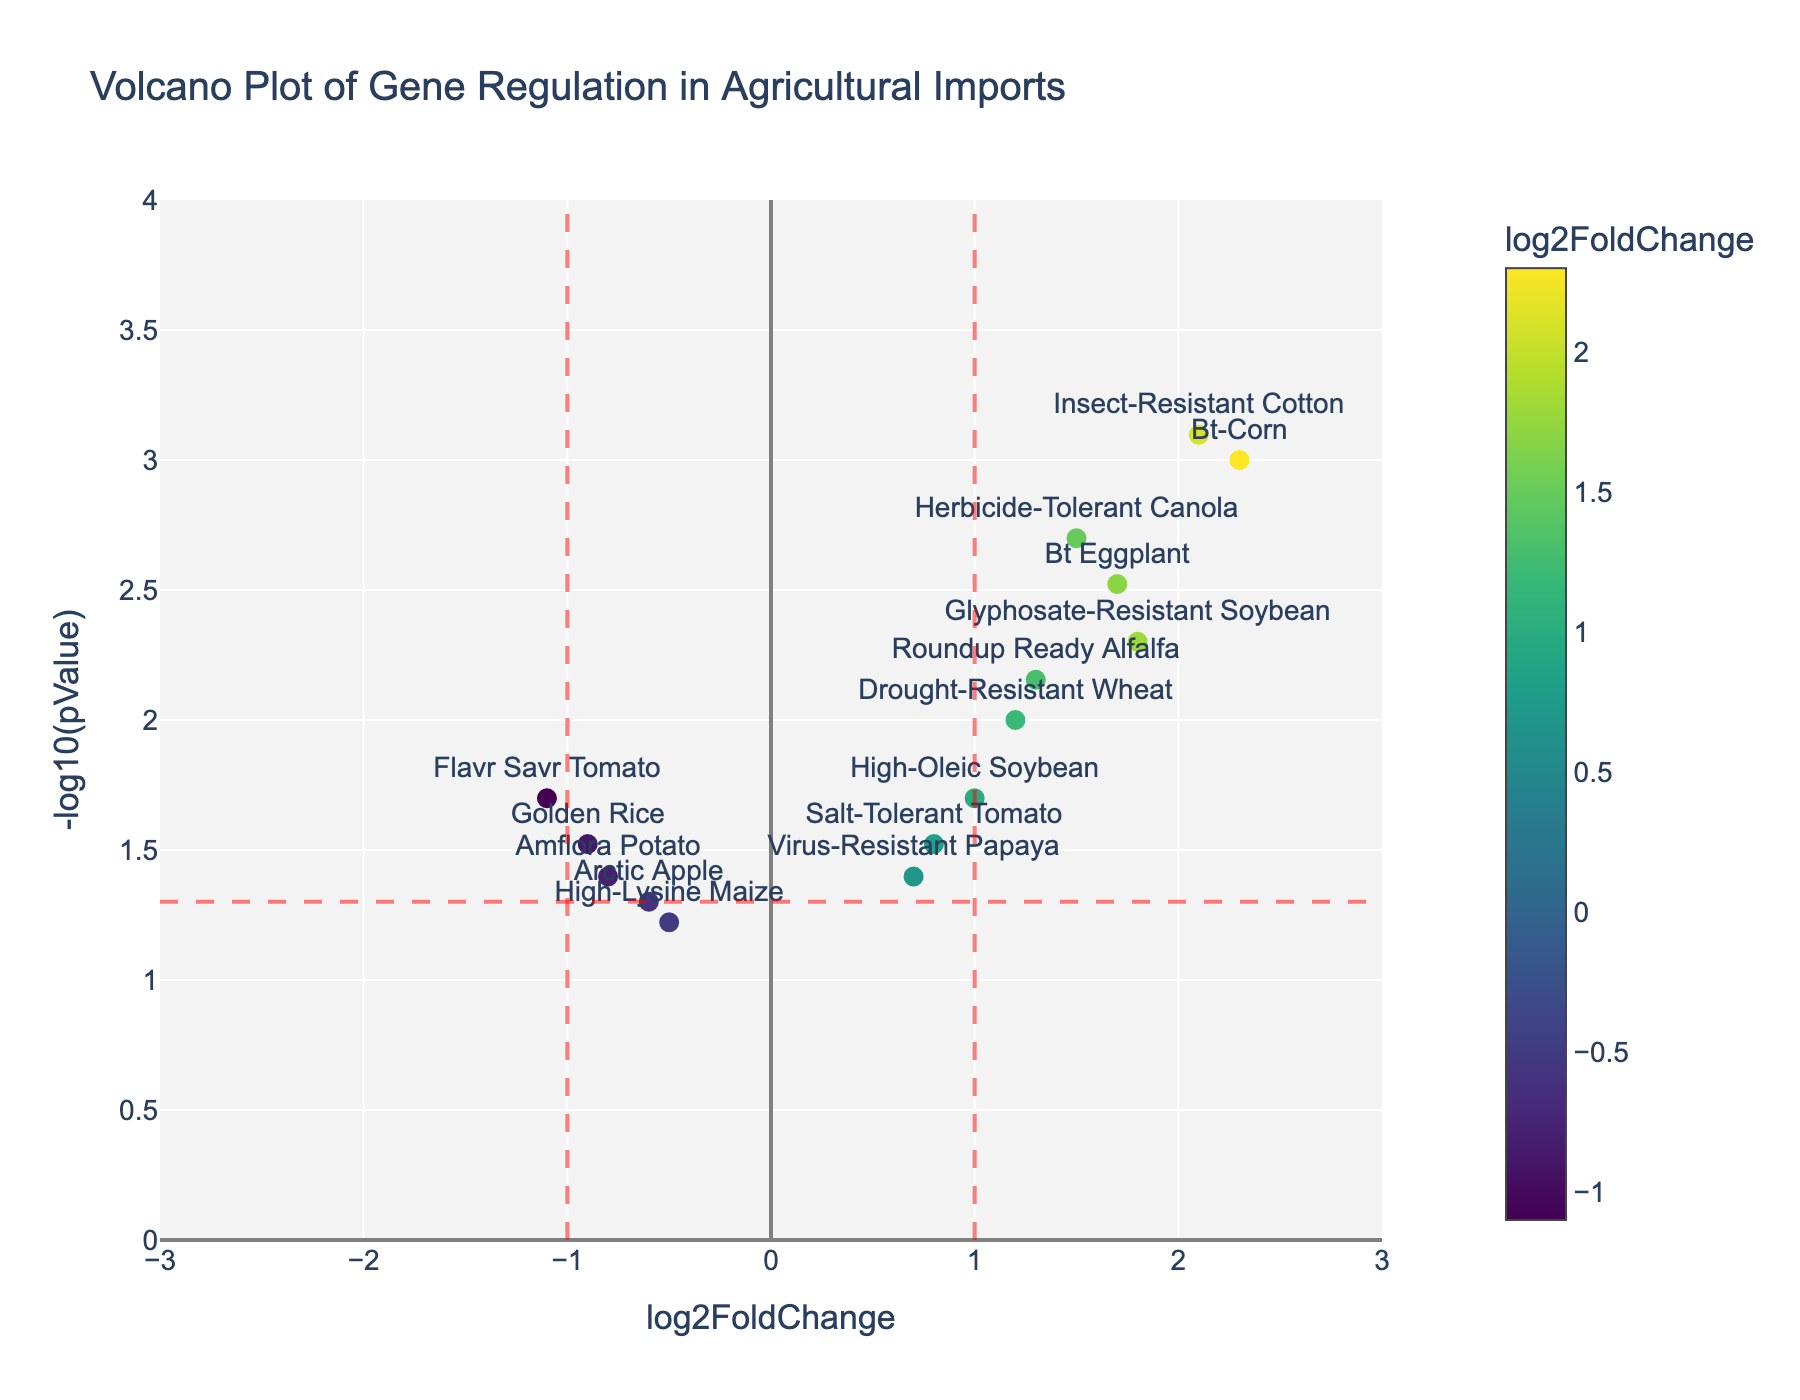How many genes show a significant log2FoldChange greater than 1? We consider a log2FoldChange significant if the value is greater than 1 and the p-value is less than 0.05. By looking at the plot, we find that Bt-Corn, Glyphosate-Resistant Soybean, Herbicide-Tolerant Canola, Insect-Resistant Cotton, Roundup Ready Alfalfa, and Bt Eggplant satisfy these conditions.
Answer: 6 Which gene has the highest -log10(pValue)? The -log10(pValue) indicates significance; the higher it is, the more significant the p-value. From the plot's y-axis, the highest -log10(pValue) is for Insect-Resistant Cotton.
Answer: Insect-Resistant Cotton What is the fold change and p-value for the gene Golden Rice? By examining the gene Golden Rice on the plot, we see that the log2FoldChange is -0.9 and the p-value is 0.03.
Answer: -0.9, 0.03 Which genes are considered upregulated and among those, which one is closest to the log2FoldChange threshold of 1? Upregulated genes have a positive log2FoldChange. The genes closest to the threshold log2FoldChange of 1 are identified. Between Drought-Resistant Wheat (1.2), Herbicide-Tolerant Canola (1.5), Roundup Ready Alfalfa (1.3), Bt Eggplant (1.7), and Glyphosate-Resistant Soybean (1.8), Drought-Resistant Wheat is the closest.
Answer: Drought-Resistant Wheat Are there more upregulated or downregulated genes overall? Upregulated genes have a positive log2FoldChange, and downregulated genes have a negative log2FoldChange. Counting each, we find there are 10 upregulated (positive values) and 5 downregulated (negative values).
Answer: Upregulated What log2FoldChange and pValue trend does Flavr Savr Tomato exhibit? Inspecting the plot for Flavr Savr Tomato, it has a log2FoldChange of -1.1 and a p-value of 0.02, indicating significant downregulation.
Answer: -1.1, 0.02 Which gene has the second-highest log2FoldChange and what is it? From the plot, the gene with the second-highest log2FoldChange can be determined by inspecting the x-axis. The second-highest log2FoldChange is for Bt-Corn with a value of 2.3.
Answer: Bt-Corn, 2.3 How many genes are not considered statistically significant? A gene is considered statistically significant if its p-value is less than 0.05. By plotting, the genes with p-values 0.05 or higher are spottable. We find High-Lysine Maize (0.06) and Arctic Apple (0.05) are not significant.
Answer: 2 Which gene shows the least significant p-value? The least significant p-value will have the smallest -log10(pValue) and correspondingly the highest p-value. Both High-Lysine Maize shows the p-value of 0.06, the highest among the dataset when checking the plot.
Answer: High-Lysine Maize Which crop variety is significantly downregulated, with a log2FoldChange less than -0.8? To be significantly downregulated (log2FoldChange < -0.8), and significant (p-value < 0.05), Golden Rice (-0.9) and Flavr Savr Tomato (-1.1) fit the criteria from the plot. Both show clear negativity.
Answer: Golden Rice, Flavr Savr Tomato 